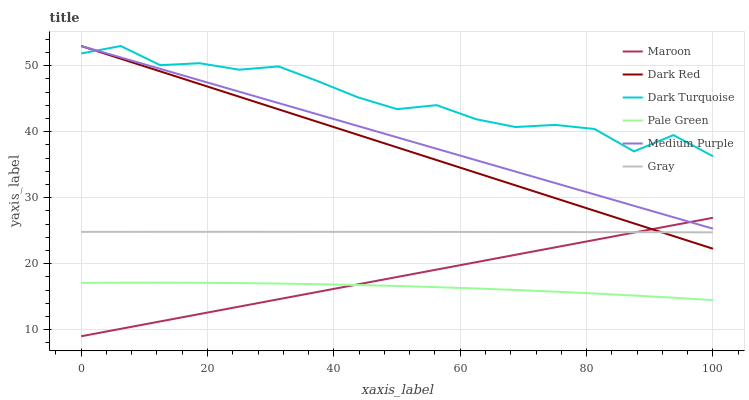Does Pale Green have the minimum area under the curve?
Answer yes or no. Yes. Does Dark Turquoise have the maximum area under the curve?
Answer yes or no. Yes. Does Dark Red have the minimum area under the curve?
Answer yes or no. No. Does Dark Red have the maximum area under the curve?
Answer yes or no. No. Is Medium Purple the smoothest?
Answer yes or no. Yes. Is Dark Turquoise the roughest?
Answer yes or no. Yes. Is Dark Red the smoothest?
Answer yes or no. No. Is Dark Red the roughest?
Answer yes or no. No. Does Maroon have the lowest value?
Answer yes or no. Yes. Does Dark Red have the lowest value?
Answer yes or no. No. Does Dark Turquoise have the highest value?
Answer yes or no. Yes. Does Maroon have the highest value?
Answer yes or no. No. Is Gray less than Dark Turquoise?
Answer yes or no. Yes. Is Dark Turquoise greater than Maroon?
Answer yes or no. Yes. Does Dark Red intersect Medium Purple?
Answer yes or no. Yes. Is Dark Red less than Medium Purple?
Answer yes or no. No. Is Dark Red greater than Medium Purple?
Answer yes or no. No. Does Gray intersect Dark Turquoise?
Answer yes or no. No. 